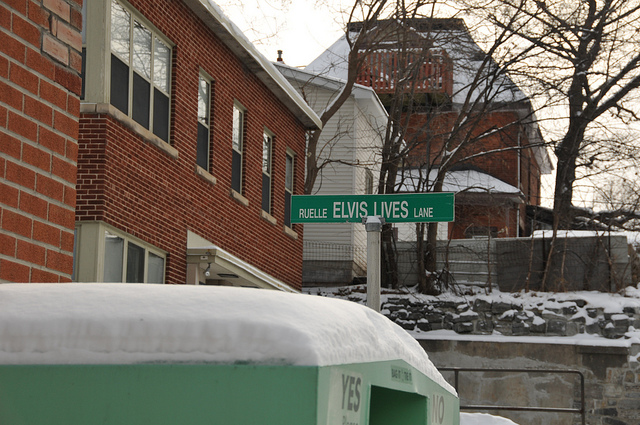Read and extract the text from this image. RUELLE ELVIS LIVES LANE YES NO 